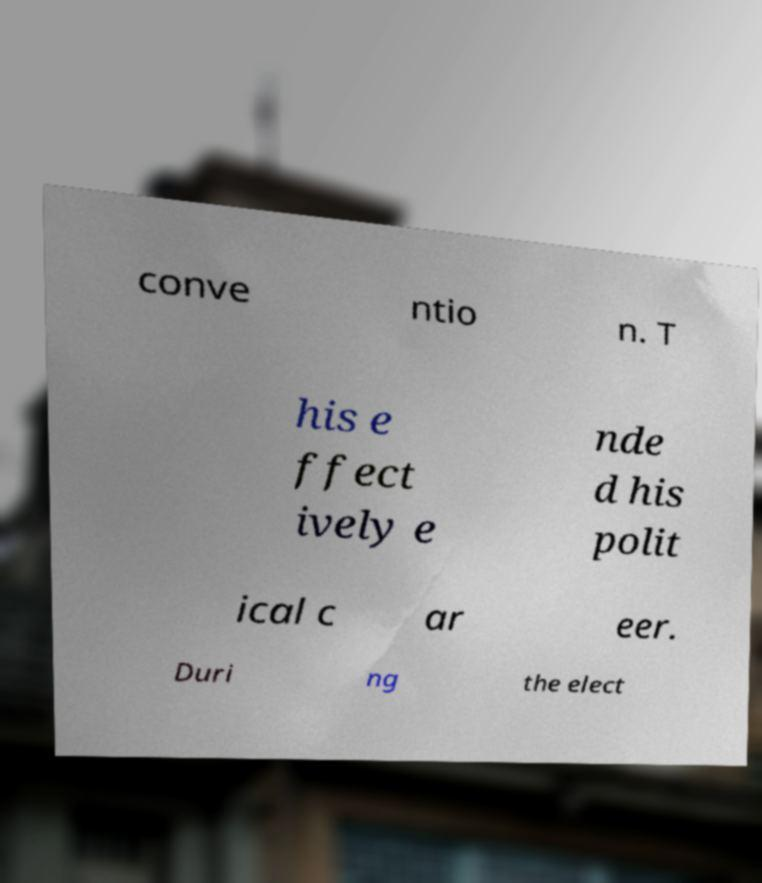Could you extract and type out the text from this image? conve ntio n. T his e ffect ively e nde d his polit ical c ar eer. Duri ng the elect 